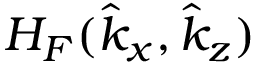<formula> <loc_0><loc_0><loc_500><loc_500>H _ { F } ( \hat { k } _ { x } , \hat { k } _ { z } )</formula> 